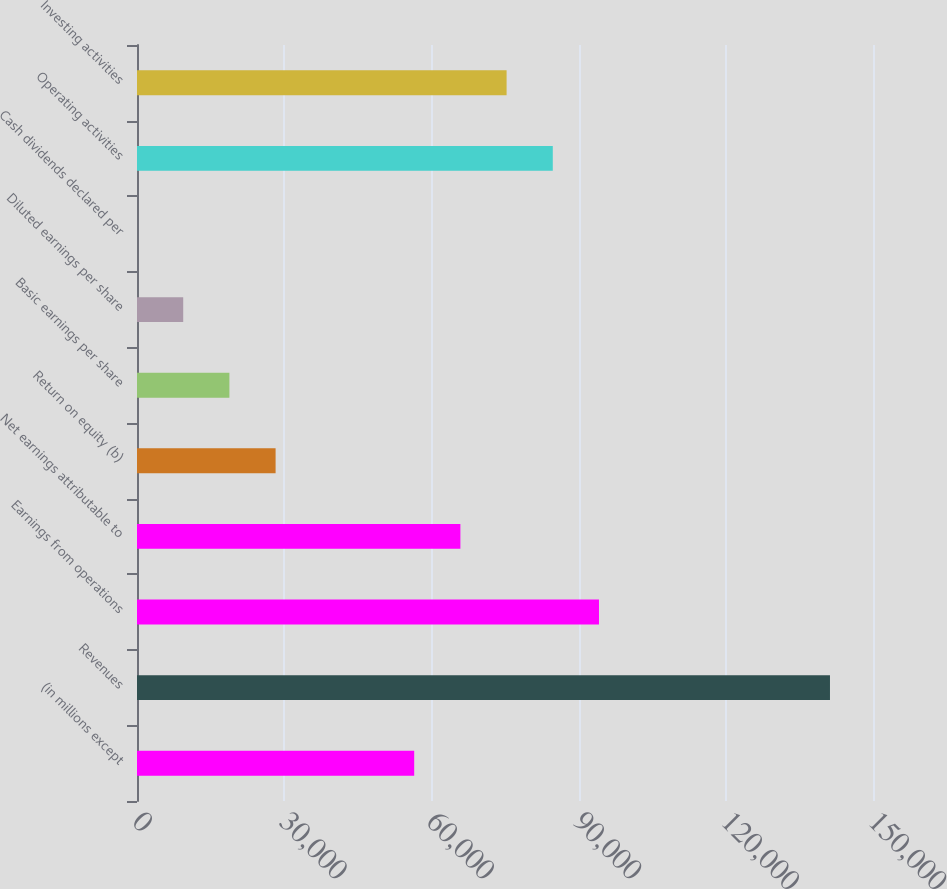Convert chart to OTSL. <chart><loc_0><loc_0><loc_500><loc_500><bar_chart><fcel>(in millions except<fcel>Revenues<fcel>Earnings from operations<fcel>Net earnings attributable to<fcel>Return on equity (b)<fcel>Basic earnings per share<fcel>Diluted earnings per share<fcel>Cash dividends declared per<fcel>Operating activities<fcel>Investing activities<nl><fcel>56493.2<fcel>141232<fcel>94155<fcel>65908.6<fcel>28246.8<fcel>18831.3<fcel>9415.87<fcel>0.41<fcel>84739.6<fcel>75324.1<nl></chart> 